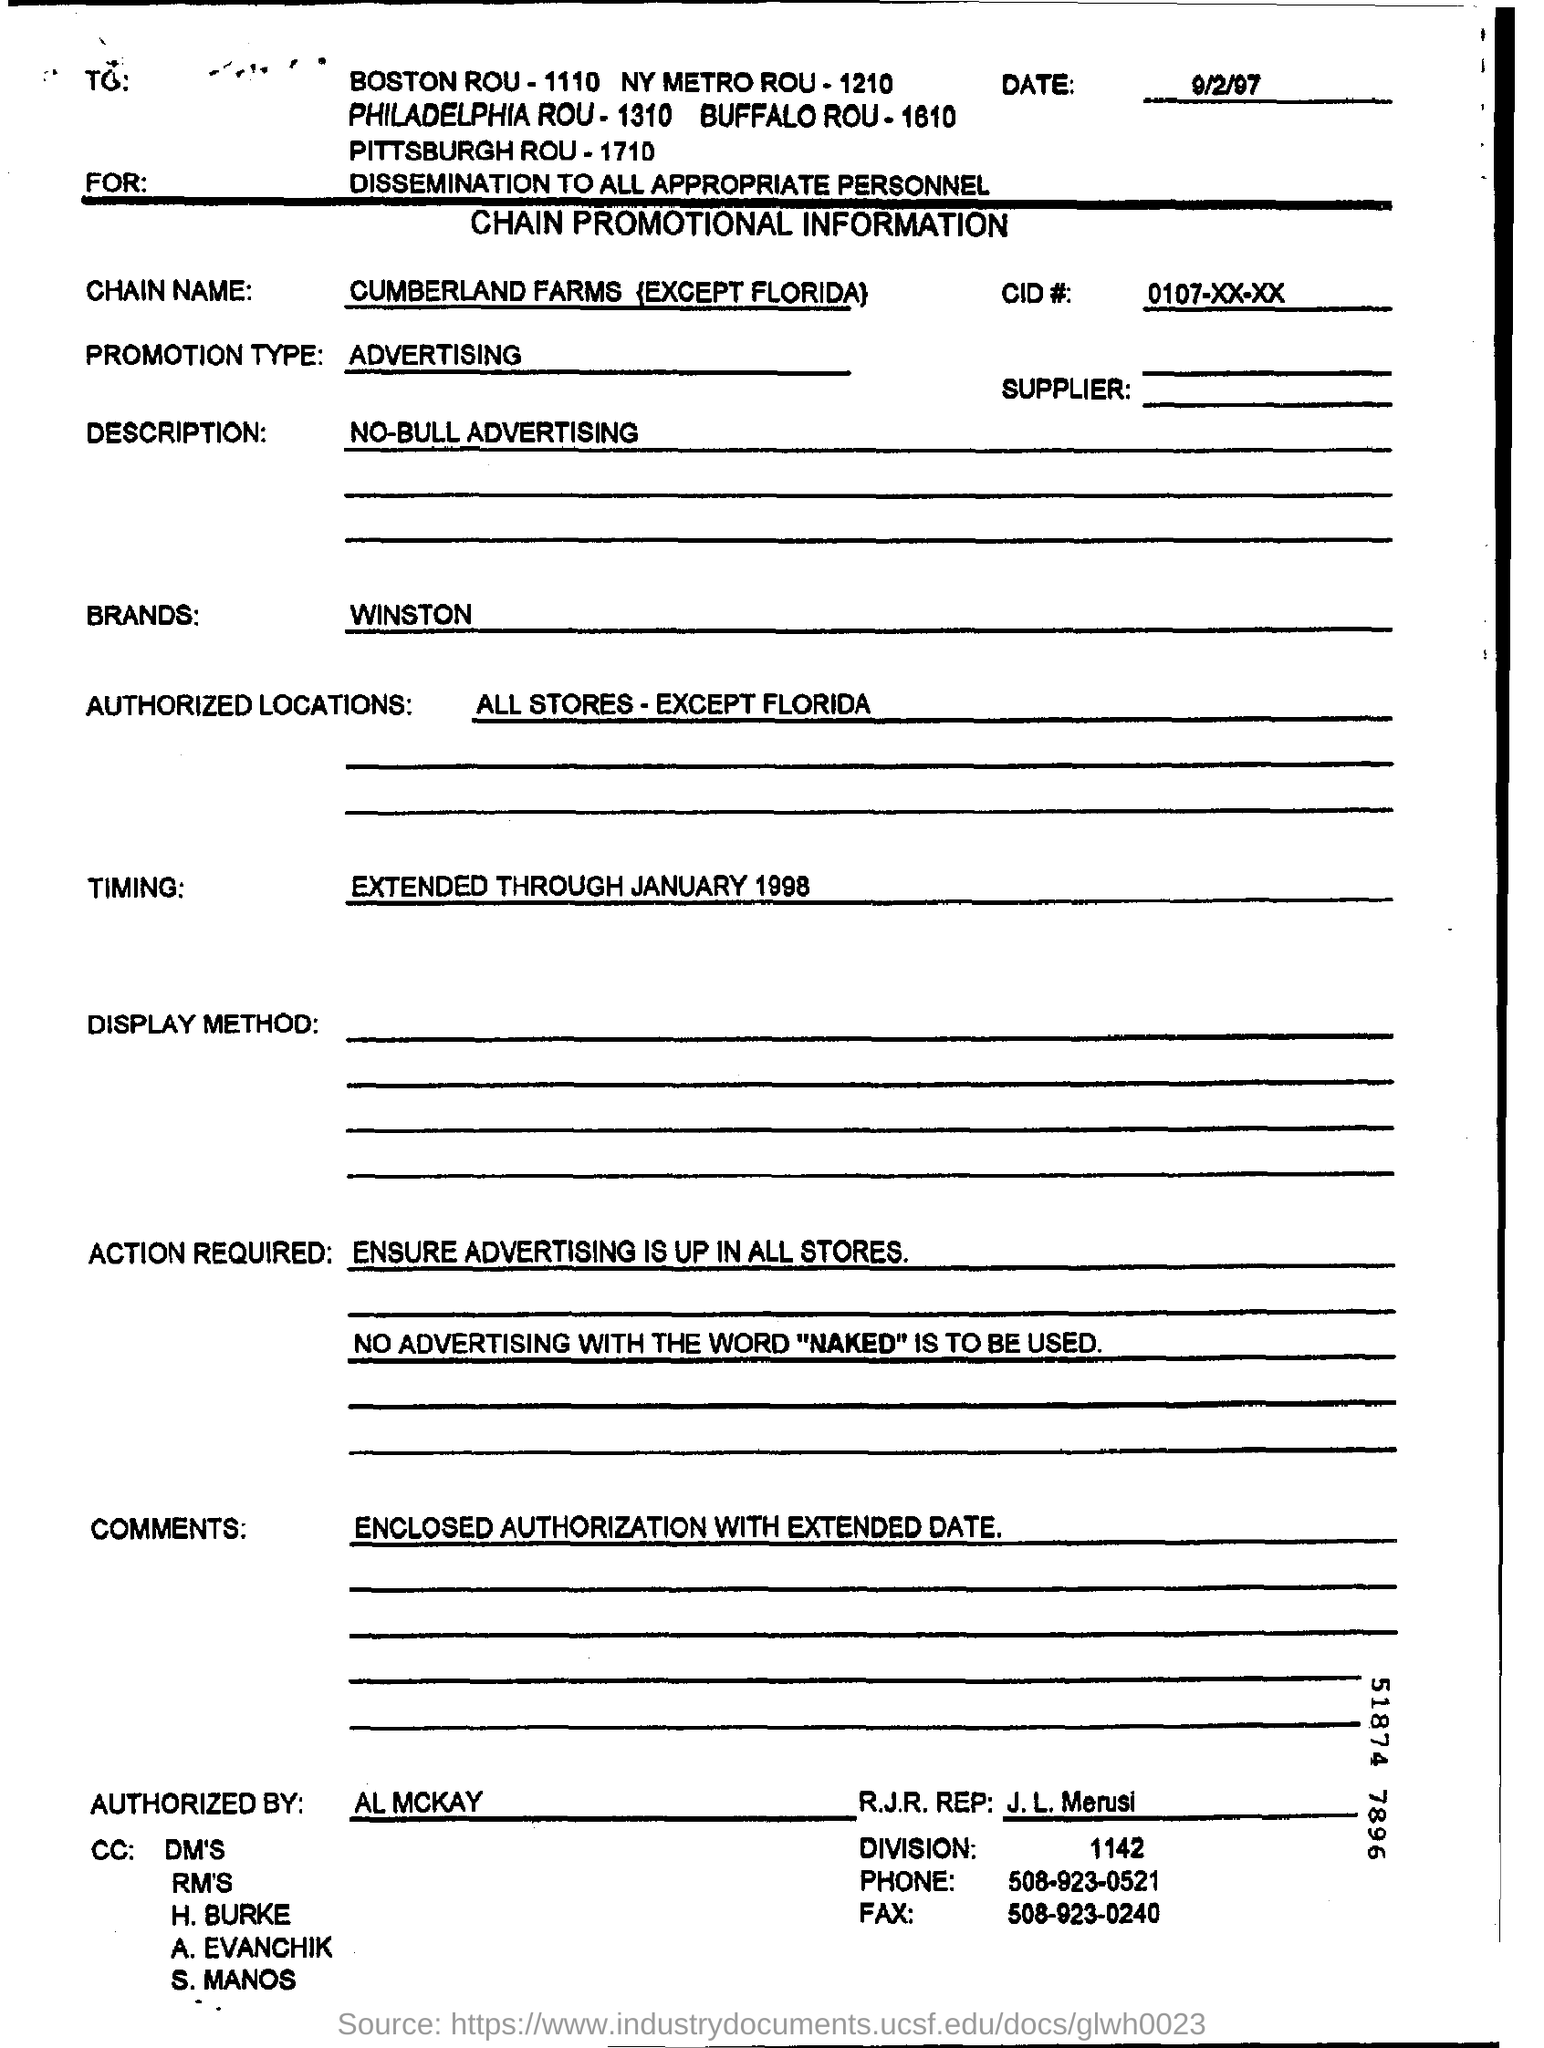Point out several critical features in this image. I, AL MCKAY, have authorized this form. What is the R.J.R. REP FAX number? 508-923-0240... Authorized locations are those with the exception of Florida. Cumberland Farms, with the exception of its locations in Florida, is known as CHAIN NAME. 